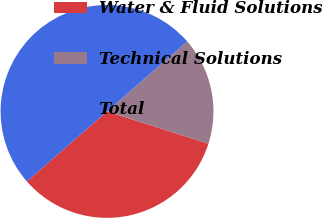Convert chart. <chart><loc_0><loc_0><loc_500><loc_500><pie_chart><fcel>Water & Fluid Solutions<fcel>Technical Solutions<fcel>Total<nl><fcel>33.68%<fcel>16.32%<fcel>50.0%<nl></chart> 